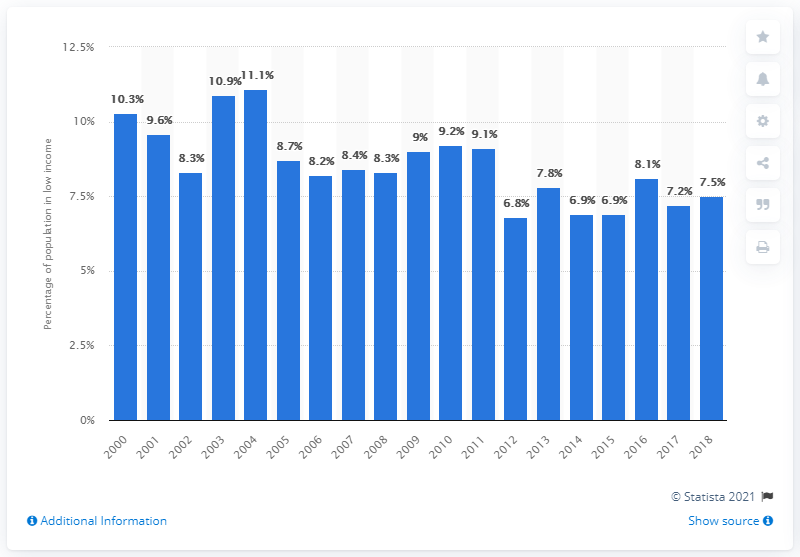List a handful of essential elements in this visual. In 2018, approximately 7.5% of Alberta's population was considered to be in low income. 